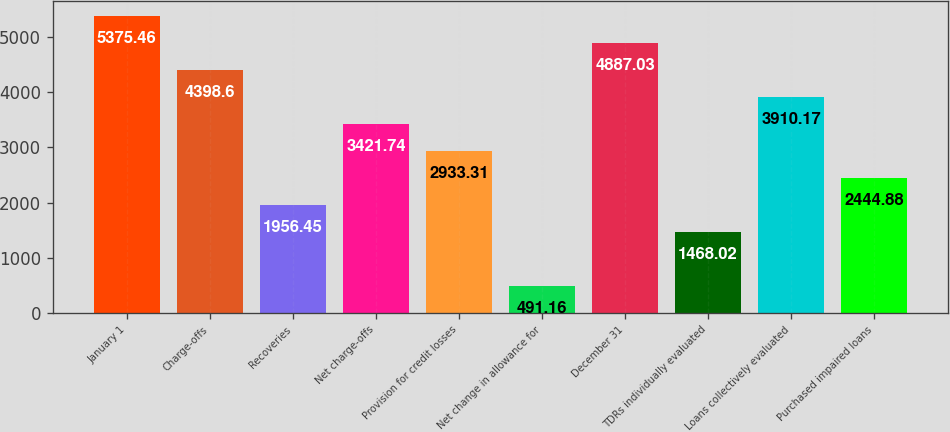Convert chart to OTSL. <chart><loc_0><loc_0><loc_500><loc_500><bar_chart><fcel>January 1<fcel>Charge-offs<fcel>Recoveries<fcel>Net charge-offs<fcel>Provision for credit losses<fcel>Net change in allowance for<fcel>December 31<fcel>TDRs individually evaluated<fcel>Loans collectively evaluated<fcel>Purchased impaired loans<nl><fcel>5375.46<fcel>4398.6<fcel>1956.45<fcel>3421.74<fcel>2933.31<fcel>491.16<fcel>4887.03<fcel>1468.02<fcel>3910.17<fcel>2444.88<nl></chart> 